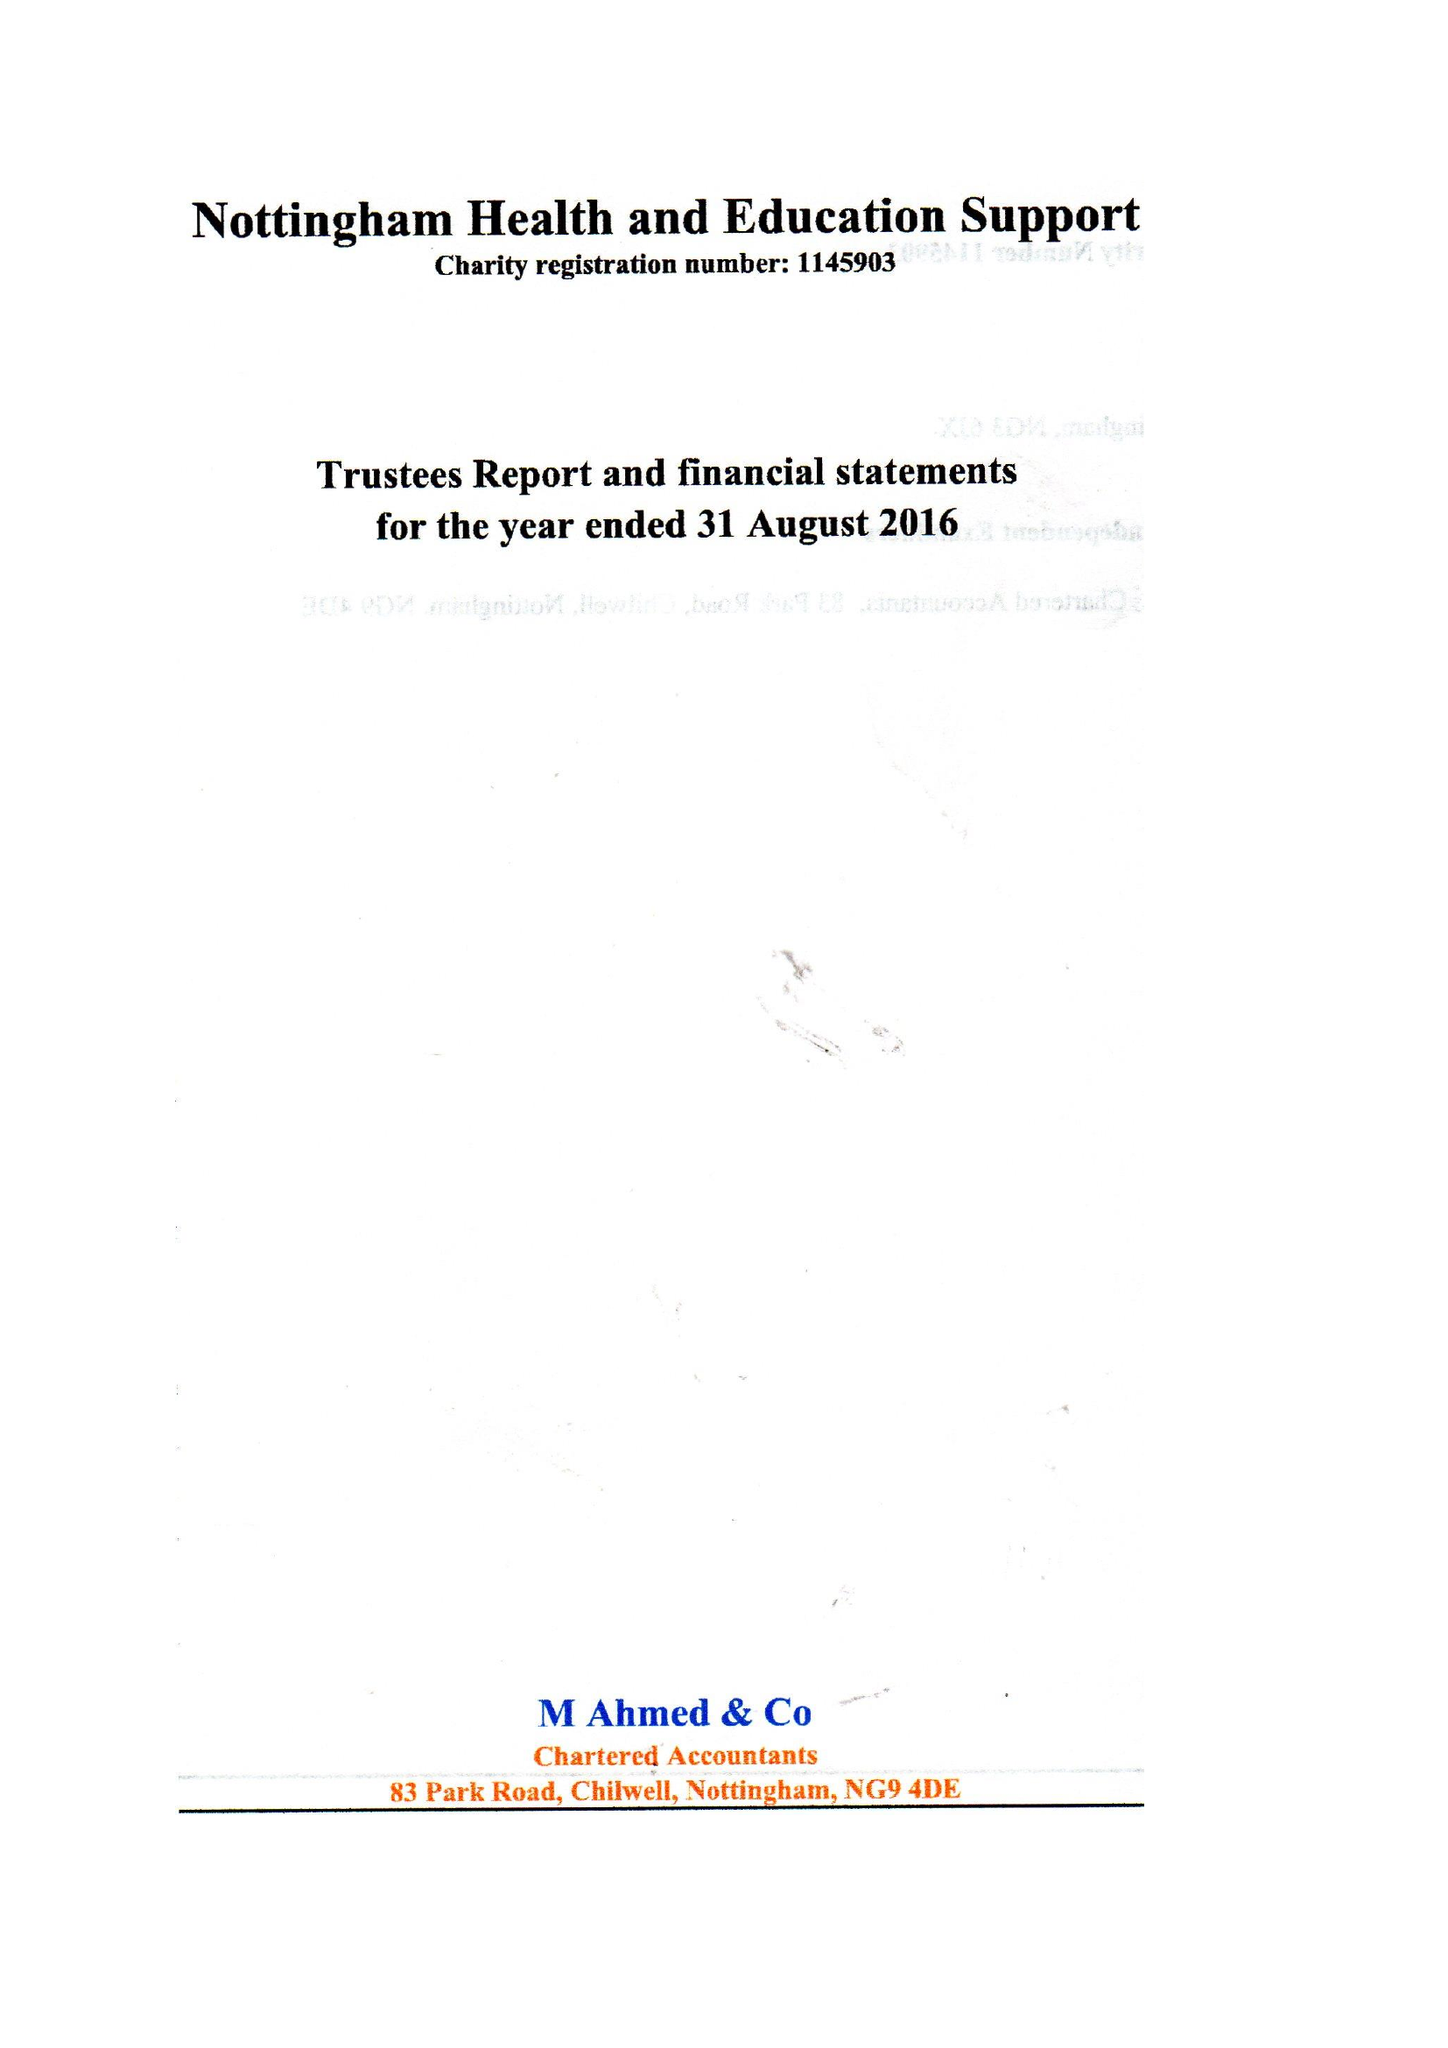What is the value for the address__street_line?
Answer the question using a single word or phrase. 9 CLAYGATE 